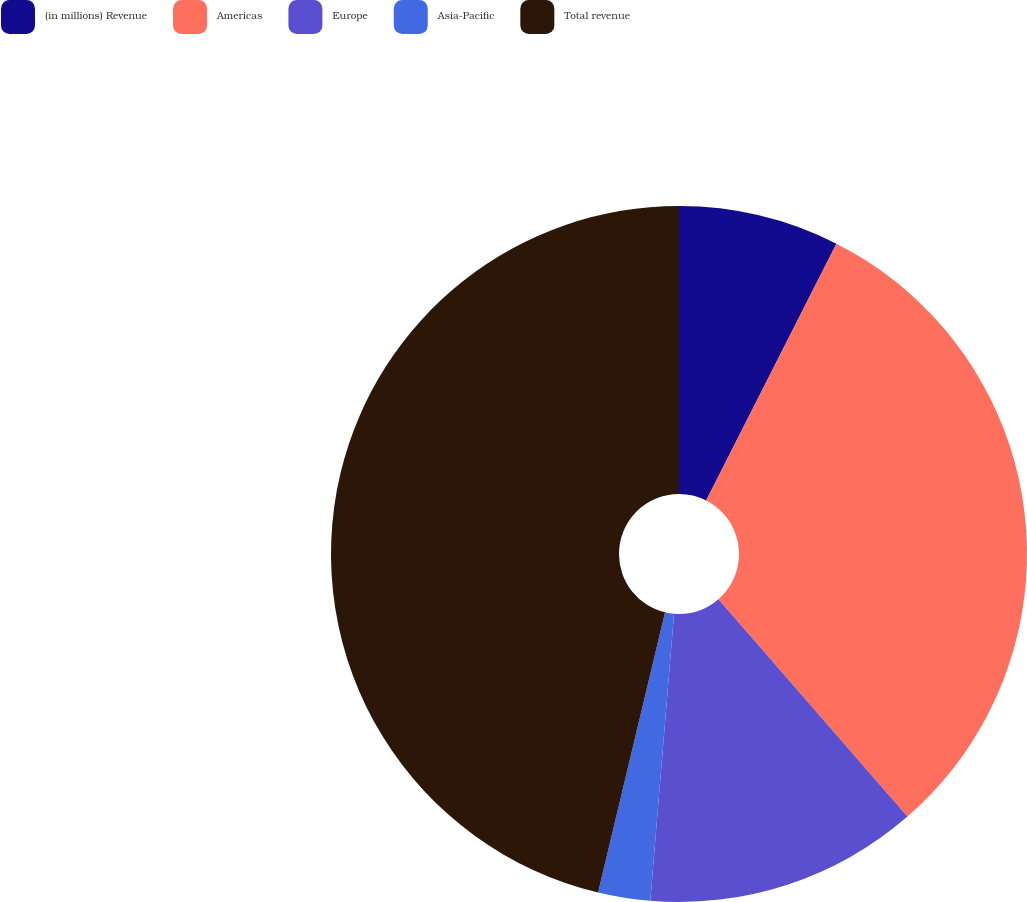Convert chart to OTSL. <chart><loc_0><loc_0><loc_500><loc_500><pie_chart><fcel>(in millions) Revenue<fcel>Americas<fcel>Europe<fcel>Asia-Pacific<fcel>Total revenue<nl><fcel>7.47%<fcel>31.13%<fcel>12.71%<fcel>2.42%<fcel>46.26%<nl></chart> 